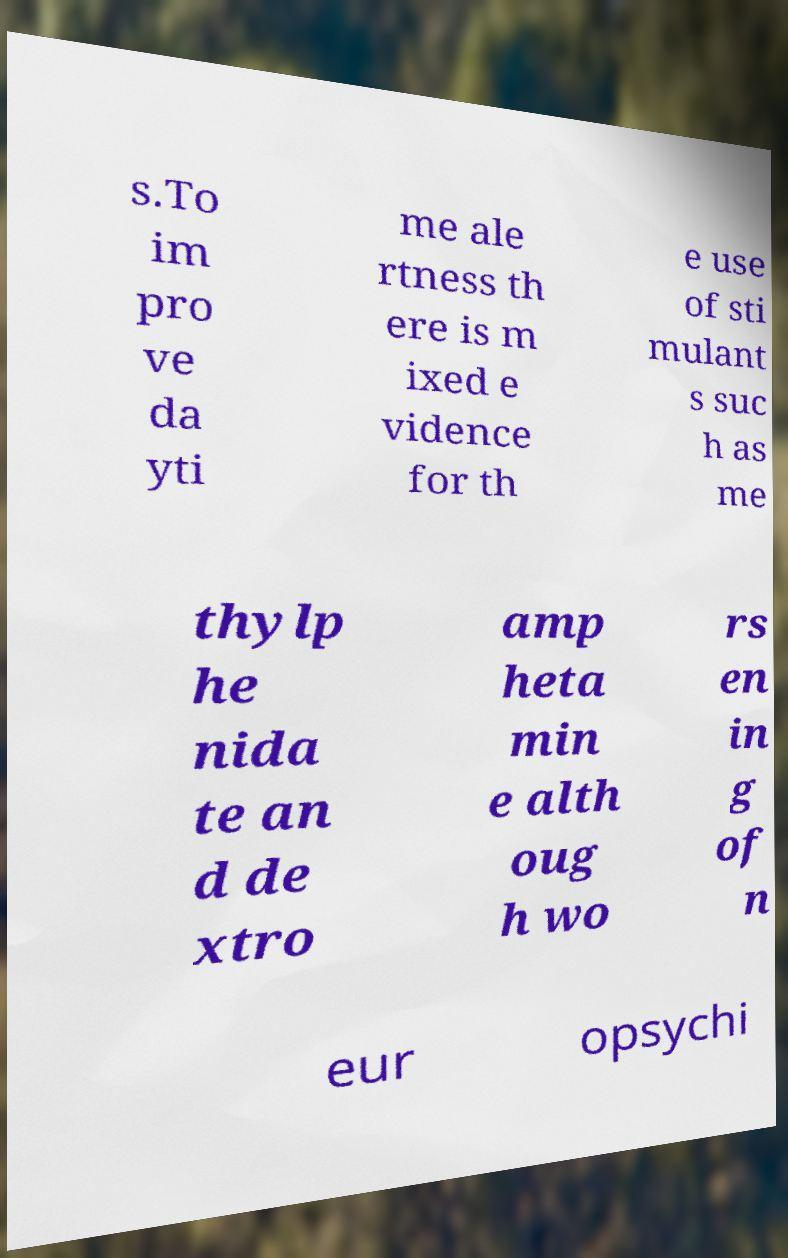Can you read and provide the text displayed in the image?This photo seems to have some interesting text. Can you extract and type it out for me? s.To im pro ve da yti me ale rtness th ere is m ixed e vidence for th e use of sti mulant s suc h as me thylp he nida te an d de xtro amp heta min e alth oug h wo rs en in g of n eur opsychi 